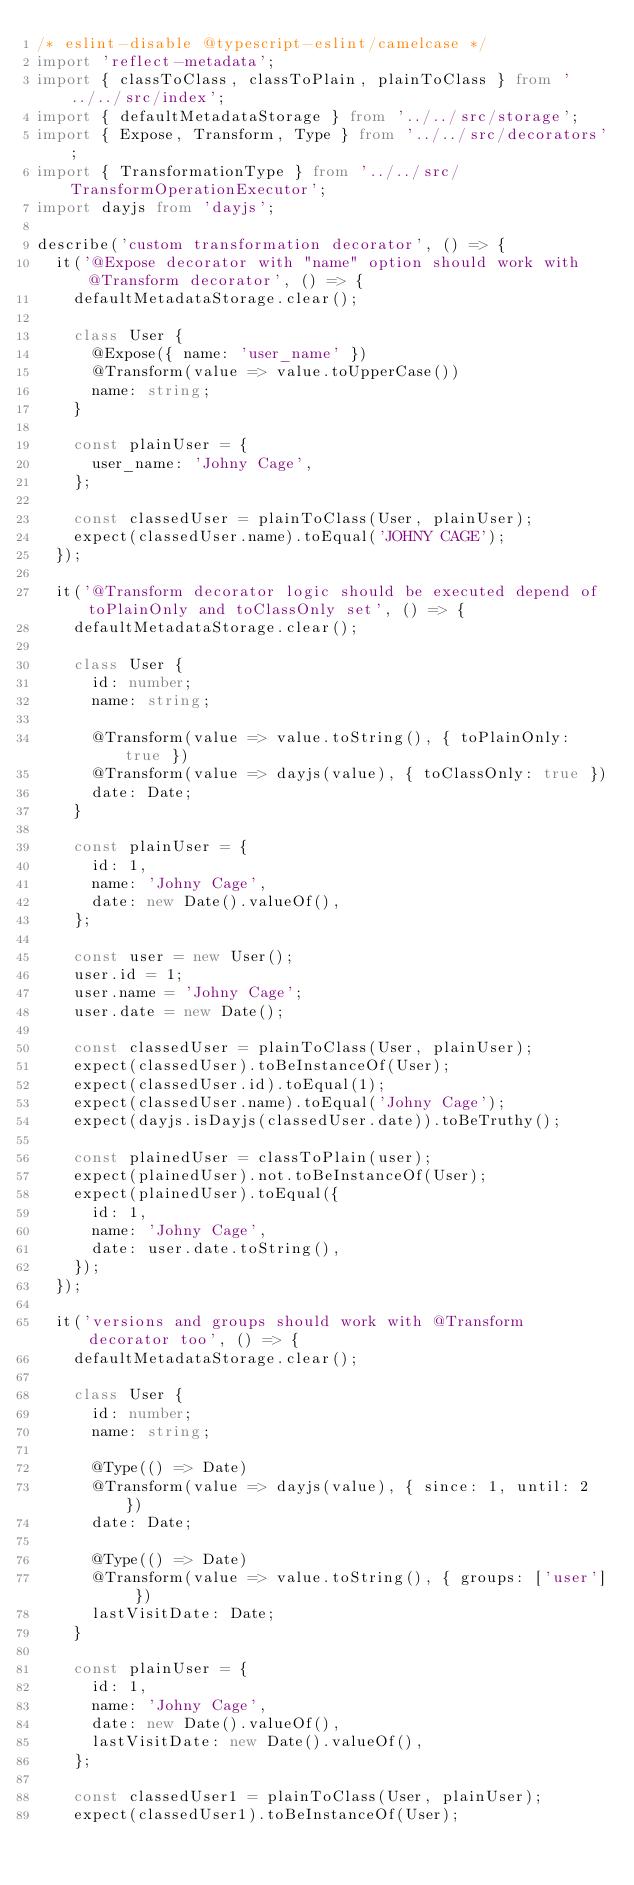<code> <loc_0><loc_0><loc_500><loc_500><_TypeScript_>/* eslint-disable @typescript-eslint/camelcase */
import 'reflect-metadata';
import { classToClass, classToPlain, plainToClass } from '../../src/index';
import { defaultMetadataStorage } from '../../src/storage';
import { Expose, Transform, Type } from '../../src/decorators';
import { TransformationType } from '../../src/TransformOperationExecutor';
import dayjs from 'dayjs';

describe('custom transformation decorator', () => {
  it('@Expose decorator with "name" option should work with @Transform decorator', () => {
    defaultMetadataStorage.clear();

    class User {
      @Expose({ name: 'user_name' })
      @Transform(value => value.toUpperCase())
      name: string;
    }

    const plainUser = {
      user_name: 'Johny Cage',
    };

    const classedUser = plainToClass(User, plainUser);
    expect(classedUser.name).toEqual('JOHNY CAGE');
  });

  it('@Transform decorator logic should be executed depend of toPlainOnly and toClassOnly set', () => {
    defaultMetadataStorage.clear();

    class User {
      id: number;
      name: string;

      @Transform(value => value.toString(), { toPlainOnly: true })
      @Transform(value => dayjs(value), { toClassOnly: true })
      date: Date;
    }

    const plainUser = {
      id: 1,
      name: 'Johny Cage',
      date: new Date().valueOf(),
    };

    const user = new User();
    user.id = 1;
    user.name = 'Johny Cage';
    user.date = new Date();

    const classedUser = plainToClass(User, plainUser);
    expect(classedUser).toBeInstanceOf(User);
    expect(classedUser.id).toEqual(1);
    expect(classedUser.name).toEqual('Johny Cage');
    expect(dayjs.isDayjs(classedUser.date)).toBeTruthy();

    const plainedUser = classToPlain(user);
    expect(plainedUser).not.toBeInstanceOf(User);
    expect(plainedUser).toEqual({
      id: 1,
      name: 'Johny Cage',
      date: user.date.toString(),
    });
  });

  it('versions and groups should work with @Transform decorator too', () => {
    defaultMetadataStorage.clear();

    class User {
      id: number;
      name: string;

      @Type(() => Date)
      @Transform(value => dayjs(value), { since: 1, until: 2 })
      date: Date;

      @Type(() => Date)
      @Transform(value => value.toString(), { groups: ['user'] })
      lastVisitDate: Date;
    }

    const plainUser = {
      id: 1,
      name: 'Johny Cage',
      date: new Date().valueOf(),
      lastVisitDate: new Date().valueOf(),
    };

    const classedUser1 = plainToClass(User, plainUser);
    expect(classedUser1).toBeInstanceOf(User);</code> 